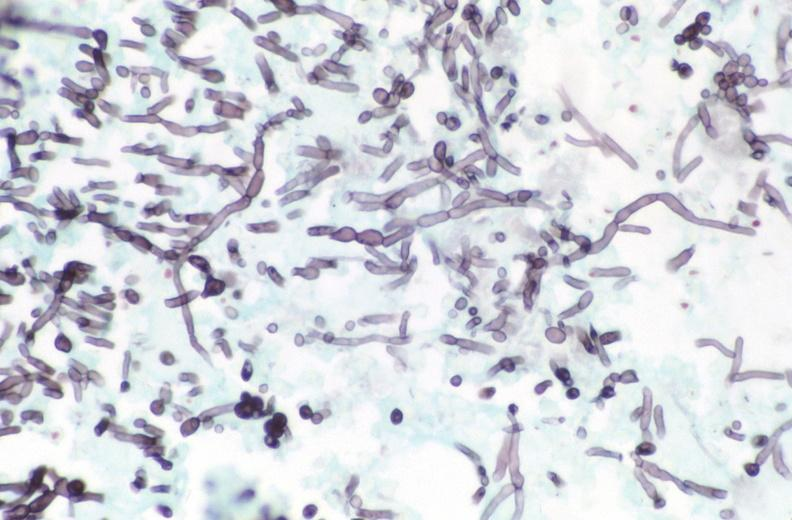what stain?
Answer the question using a single word or phrase. Esohagus, candida, silver 